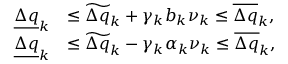Convert formula to latex. <formula><loc_0><loc_0><loc_500><loc_500>\begin{array} { r l } { \underline { \Delta q } _ { k } } & { \leq \widetilde { \Delta q } _ { k } + \gamma _ { k } b _ { k } \nu _ { k } \leq \overline { \Delta q } _ { k } , } \\ { \underline { \Delta q } _ { k } } & { \leq \widetilde { \Delta q } _ { k } - \gamma _ { k } \alpha _ { k } \nu _ { k } \leq \overline { \Delta q } _ { k } , } \end{array}</formula> 